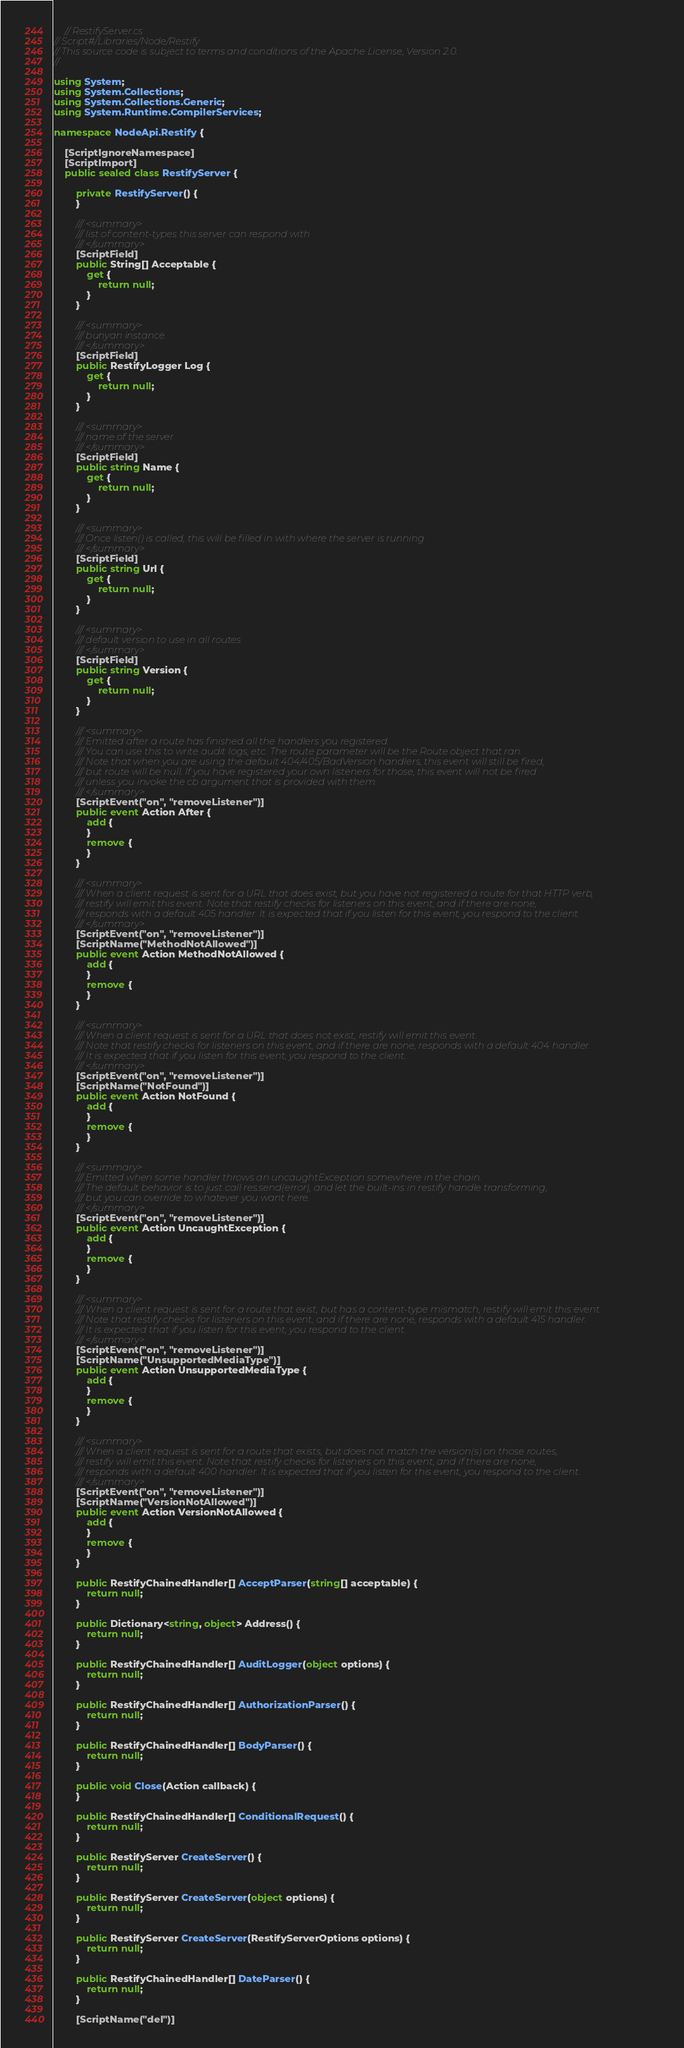Convert code to text. <code><loc_0><loc_0><loc_500><loc_500><_C#_>    // RestifyServer.cs
// Script#/Libraries/Node/Restify
// This source code is subject to terms and conditions of the Apache License, Version 2.0.
//

using System;
using System.Collections;
using System.Collections.Generic;
using System.Runtime.CompilerServices;

namespace NodeApi.Restify {

    [ScriptIgnoreNamespace]
    [ScriptImport]
    public sealed class RestifyServer {

        private RestifyServer() {
        }

        /// <summary>
        /// list of content-types this server can respond with
        /// </summary>
        [ScriptField]
        public String[] Acceptable {
            get {
                return null;
            }
        }

        /// <summary>
        /// bunyan instance
        /// </summary>
        [ScriptField]
        public RestifyLogger Log {
            get {
                return null;
            }
        }

        /// <summary>
        /// name of the server
        /// </summary>
        [ScriptField]
        public string Name {
            get {
                return null;
            }
        }

        /// <summary>
        /// Once listen() is called, this will be filled in with where the server is running
        /// </summary>
        [ScriptField]
        public string Url {
            get {
                return null;
            }
        }

        /// <summary>
        /// default version to use in all routes
        /// </summary>
        [ScriptField]
        public string Version {
            get {
                return null;
            }
        }

        /// <summary>
        /// Emitted after a route has finished all the handlers you registered.
        /// You can use this to write audit logs, etc. The route parameter will be the Route object that ran.
        /// Note that when you are using the default 404/405/BadVersion handlers, this event will still be fired,
        /// but route will be null. If you have registered your own listeners for those, this event will not be fired
        /// unless you invoke the cb argument that is provided with them.
        /// </summary>
        [ScriptEvent("on", "removeListener")]
        public event Action After {
            add {
            }
            remove {
            }
        }

        /// <summary>
        /// When a client request is sent for a URL that does exist, but you have not registered a route for that HTTP verb,
        /// restify will emit this event. Note that restify checks for listeners on this event, and if there are none,
        /// responds with a default 405 handler. It is expected that if you listen for this event, you respond to the client.
        /// </summary>
        [ScriptEvent("on", "removeListener")]
        [ScriptName("MethodNotAllowed")]
        public event Action MethodNotAllowed {
            add {
            }
            remove {
            }
        }

        /// <summary>
        /// When a client request is sent for a URL that does not exist, restify will emit this event.
        /// Note that restify checks for listeners on this event, and if there are none, responds with a default 404 handler.
        /// It is expected that if you listen for this event, you respond to the client.
        /// </summary>
        [ScriptEvent("on", "removeListener")]
        [ScriptName("NotFound")]
        public event Action NotFound {
            add {
            }
            remove {
            }
        }

        /// <summary>
        /// Emitted when some handler throws an uncaughtException somewhere in the chain.
        /// The default behavior is to just call res.send(error), and let the built-ins in restify handle transforming,
        /// but you can override to whatever you want here.
        /// </summary>
        [ScriptEvent("on", "removeListener")]
        public event Action UncaughtException {
            add {
            }
            remove {
            }
        }

        /// <summary>
        /// When a client request is sent for a route that exist, but has a content-type mismatch, restify will emit this event.
        /// Note that restify checks for listeners on this event, and if there are none, responds with a default 415 handler.
        /// It is expected that if you listen for this event, you respond to the client.
        /// </summary>
        [ScriptEvent("on", "removeListener")]
        [ScriptName("UnsupportedMediaType")]
        public event Action UnsupportedMediaType {
            add {
            }
            remove {
            }
        }

        /// <summary>
        /// When a client request is sent for a route that exists, but does not match the version(s) on those routes,
        /// restify will emit this event. Note that restify checks for listeners on this event, and if there are none,
        /// responds with a default 400 handler. It is expected that if you listen for this event, you respond to the client.
        /// </summary>
        [ScriptEvent("on", "removeListener")]
        [ScriptName("VersionNotAllowed")]
        public event Action VersionNotAllowed {
            add {
            }
            remove {
            }
        }

        public RestifyChainedHandler[] AcceptParser(string[] acceptable) {
            return null;
        }

        public Dictionary<string, object> Address() {
            return null;
        }

        public RestifyChainedHandler[] AuditLogger(object options) {
            return null;
        }

        public RestifyChainedHandler[] AuthorizationParser() {
            return null;
        }

        public RestifyChainedHandler[] BodyParser() {
            return null;
        }

        public void Close(Action callback) {
        }

        public RestifyChainedHandler[] ConditionalRequest() {
            return null;
        }
        
        public RestifyServer CreateServer() {
            return null;
        }

        public RestifyServer CreateServer(object options) {
            return null;
        }

        public RestifyServer CreateServer(RestifyServerOptions options) {
            return null;
        }
        
        public RestifyChainedHandler[] DateParser() {
            return null;
        }

        [ScriptName("del")]</code> 